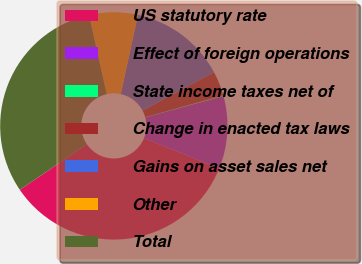<chart> <loc_0><loc_0><loc_500><loc_500><pie_chart><fcel>US statutory rate<fcel>Effect of foreign operations<fcel>State income taxes net of<fcel>Change in enacted tax laws<fcel>Gains on asset sales net<fcel>Other<fcel>Total<nl><fcel>34.4%<fcel>10.33%<fcel>0.1%<fcel>3.51%<fcel>13.75%<fcel>6.92%<fcel>30.99%<nl></chart> 